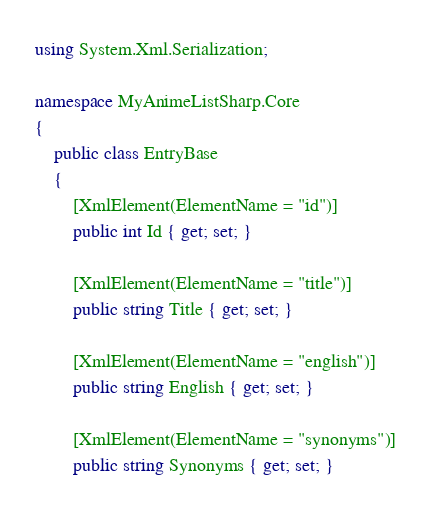Convert code to text. <code><loc_0><loc_0><loc_500><loc_500><_C#_>using System.Xml.Serialization;

namespace MyAnimeListSharp.Core
{
    public class EntryBase
    {
        [XmlElement(ElementName = "id")]
        public int Id { get; set; }

        [XmlElement(ElementName = "title")]
        public string Title { get; set; }

        [XmlElement(ElementName = "english")]
        public string English { get; set; }

        [XmlElement(ElementName = "synonyms")]
        public string Synonyms { get; set; }
</code> 